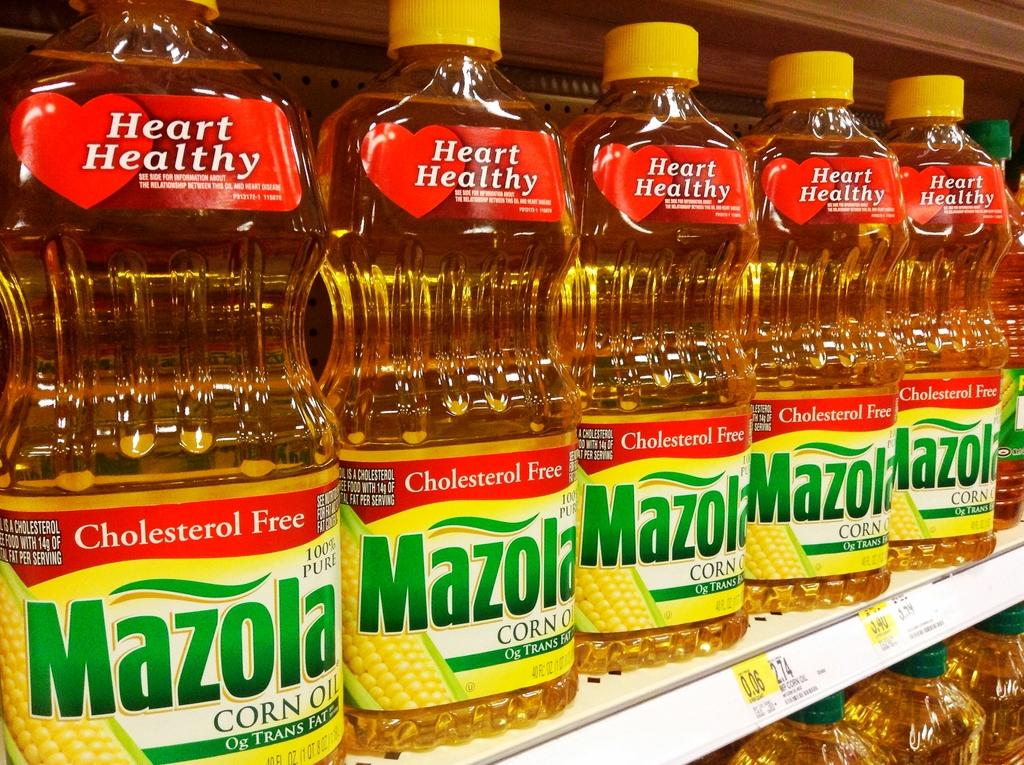<image>
Provide a brief description of the given image. A bunch of bottles of Mazola corn oil sitting on a store shelf. 